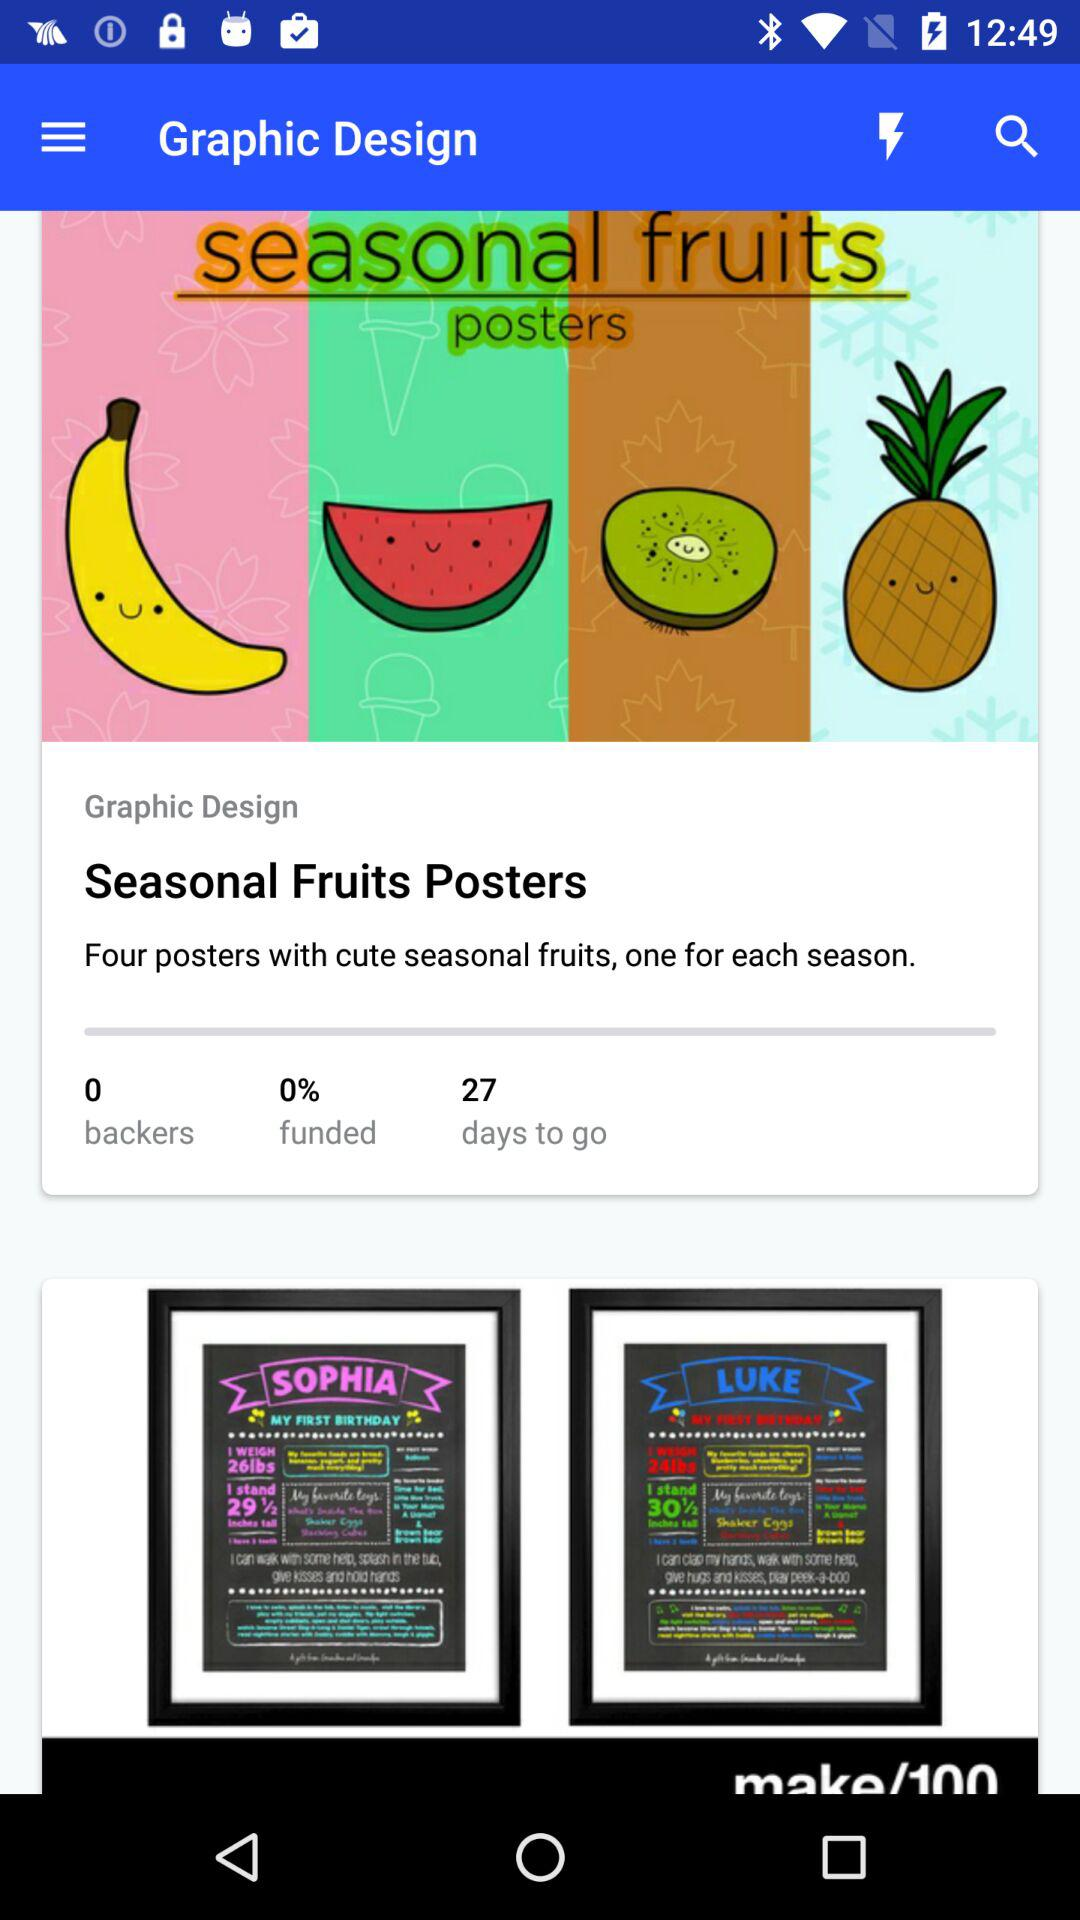How many days to go?
Answer the question using a single word or phrase. There are 27 days to go 